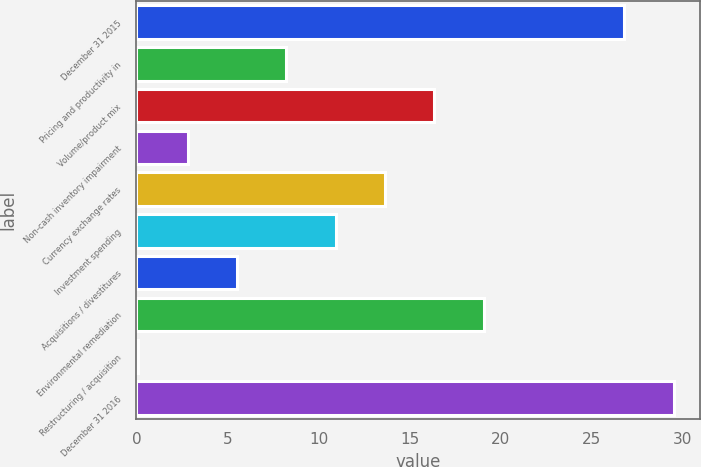Convert chart to OTSL. <chart><loc_0><loc_0><loc_500><loc_500><bar_chart><fcel>December 31 2015<fcel>Pricing and productivity in<fcel>Volume/product mix<fcel>Non-cash inventory impairment<fcel>Currency exchange rates<fcel>Investment spending<fcel>Acquisitions / divestitures<fcel>Environmental remediation<fcel>Restructuring / acquisition<fcel>December 31 2016<nl><fcel>26.8<fcel>8.23<fcel>16.36<fcel>2.81<fcel>13.65<fcel>10.94<fcel>5.52<fcel>19.07<fcel>0.1<fcel>29.51<nl></chart> 